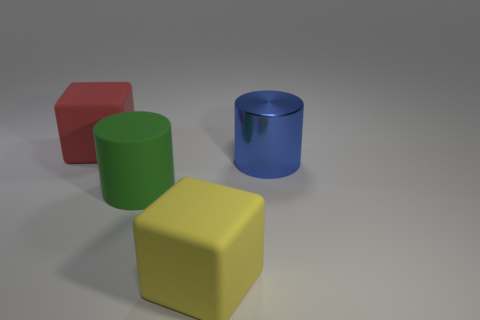Are there any green cylinders that have the same material as the big red object?
Make the answer very short. Yes. Are there fewer yellow things that are behind the rubber cylinder than blocks?
Provide a succinct answer. Yes. There is a block that is behind the yellow thing; is it the same size as the yellow block?
Offer a terse response. Yes. How many large blue metallic things are the same shape as the large green rubber object?
Offer a very short reply. 1. Are there the same number of blocks that are behind the big red matte thing and big cyan balls?
Your response must be concise. Yes. Do the big red object that is to the left of the yellow block and the big matte object that is in front of the large green matte object have the same shape?
Your response must be concise. Yes. There is a green thing that is the same shape as the blue object; what is its material?
Your response must be concise. Rubber. There is a large thing that is both in front of the red rubber object and on the left side of the big yellow rubber cube; what color is it?
Provide a succinct answer. Green. There is a large cylinder that is on the right side of the big matte block in front of the large red object; is there a blue metal thing on the left side of it?
Make the answer very short. No. How many things are blue cylinders or cubes?
Keep it short and to the point. 3. 